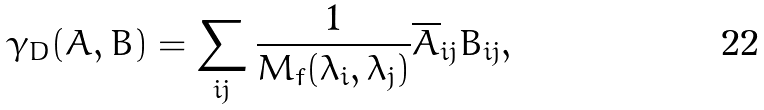Convert formula to latex. <formula><loc_0><loc_0><loc_500><loc_500>\gamma _ { D } ( A , B ) = \sum _ { i j } \frac { 1 } { M _ { f } ( \lambda _ { i } , \lambda _ { j } ) } \overline { A } _ { i j } B _ { i j } ,</formula> 